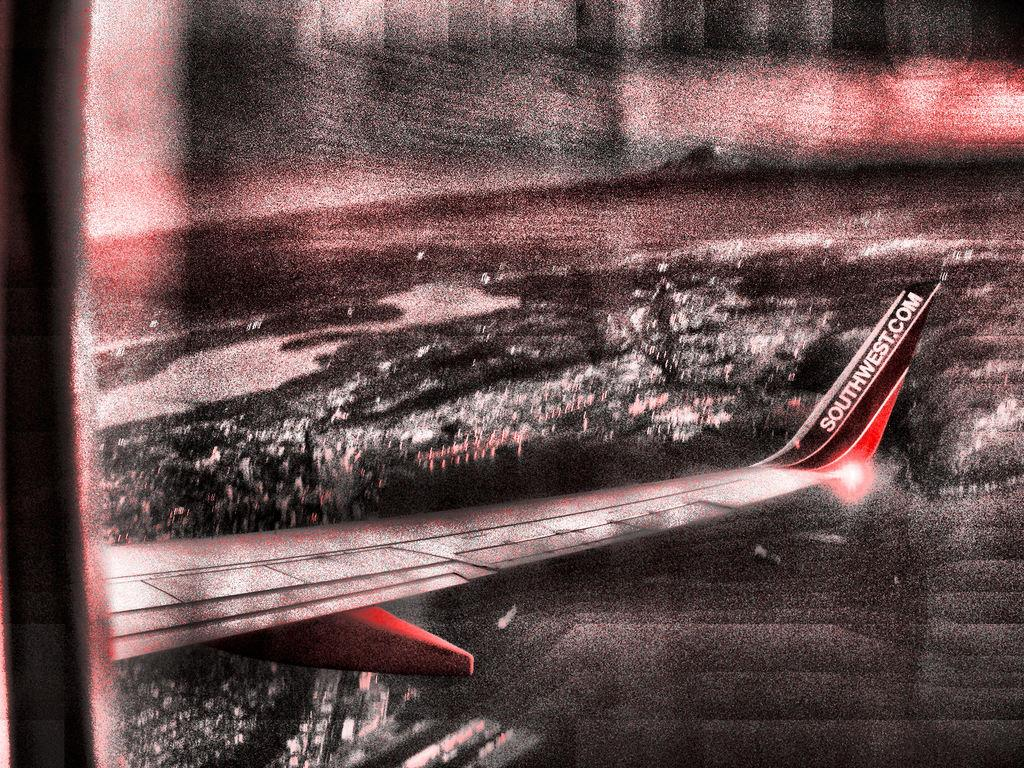<image>
Write a terse but informative summary of the picture. A plane in the dark with Southwest.com on the tail 